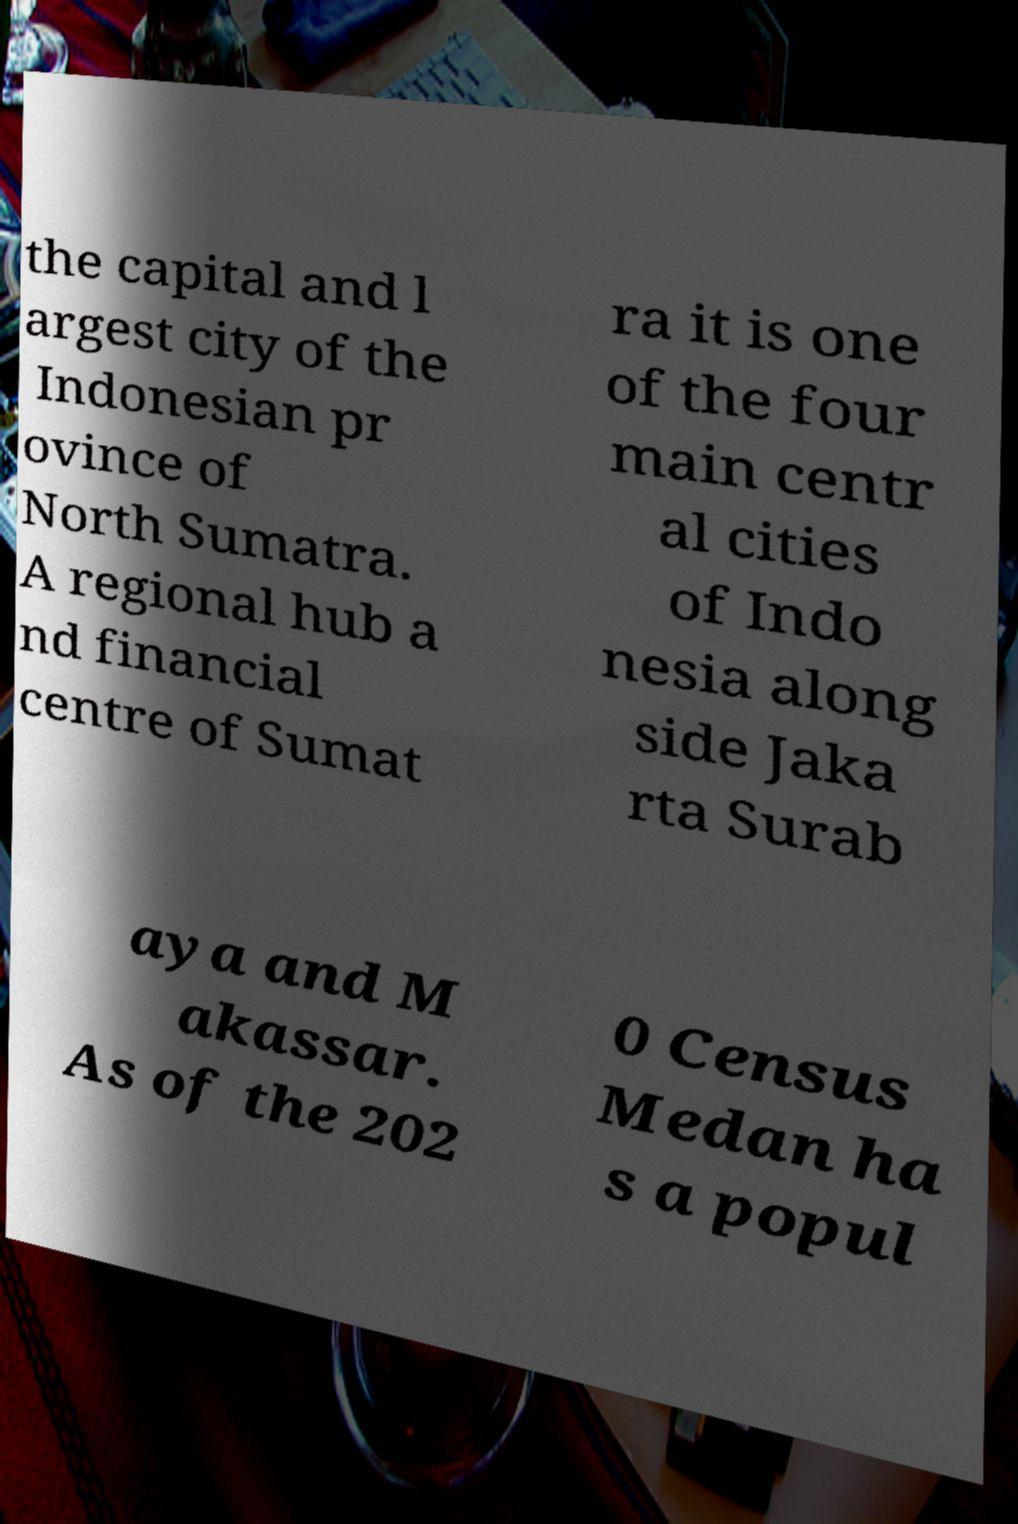For documentation purposes, I need the text within this image transcribed. Could you provide that? the capital and l argest city of the Indonesian pr ovince of North Sumatra. A regional hub a nd financial centre of Sumat ra it is one of the four main centr al cities of Indo nesia along side Jaka rta Surab aya and M akassar. As of the 202 0 Census Medan ha s a popul 